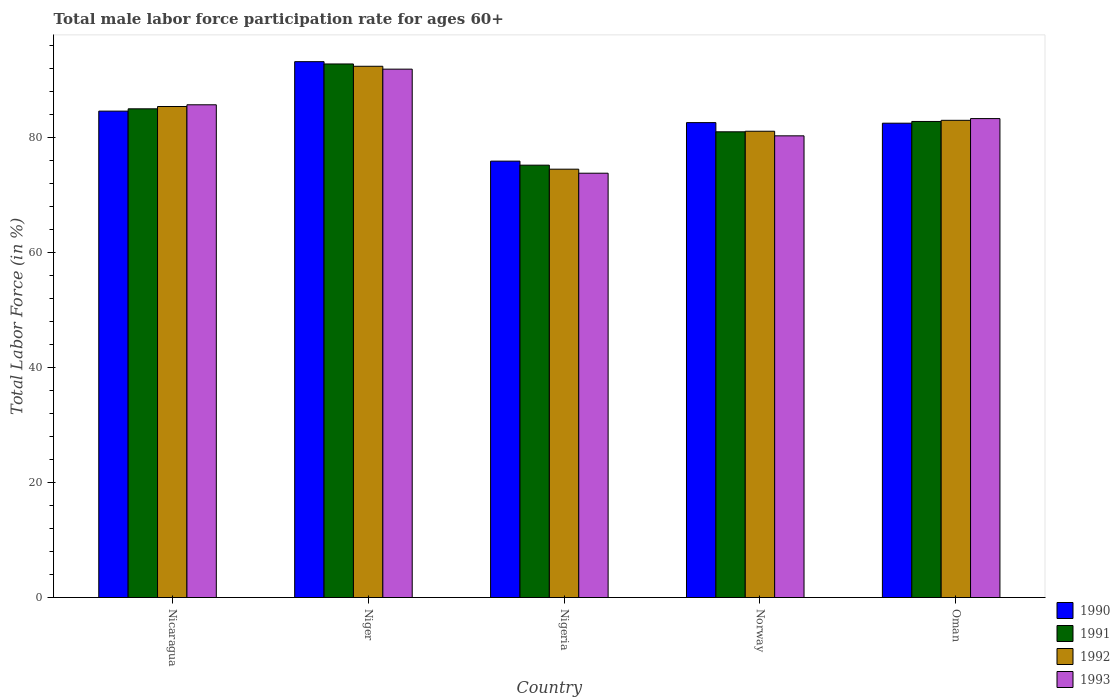Are the number of bars per tick equal to the number of legend labels?
Give a very brief answer. Yes. What is the label of the 3rd group of bars from the left?
Provide a succinct answer. Nigeria. What is the male labor force participation rate in 1990 in Nigeria?
Ensure brevity in your answer.  75.9. Across all countries, what is the maximum male labor force participation rate in 1993?
Give a very brief answer. 91.9. Across all countries, what is the minimum male labor force participation rate in 1993?
Your response must be concise. 73.8. In which country was the male labor force participation rate in 1993 maximum?
Offer a very short reply. Niger. In which country was the male labor force participation rate in 1990 minimum?
Offer a terse response. Nigeria. What is the total male labor force participation rate in 1990 in the graph?
Provide a short and direct response. 418.8. What is the difference between the male labor force participation rate in 1992 in Niger and that in Norway?
Provide a short and direct response. 11.3. What is the difference between the male labor force participation rate in 1990 in Nigeria and the male labor force participation rate in 1992 in Niger?
Provide a short and direct response. -16.5. What is the average male labor force participation rate in 1990 per country?
Make the answer very short. 83.76. What is the difference between the male labor force participation rate of/in 1992 and male labor force participation rate of/in 1991 in Nigeria?
Keep it short and to the point. -0.7. What is the ratio of the male labor force participation rate in 1991 in Nicaragua to that in Niger?
Offer a very short reply. 0.92. Is the male labor force participation rate in 1990 in Nicaragua less than that in Niger?
Make the answer very short. Yes. What is the difference between the highest and the lowest male labor force participation rate in 1990?
Provide a succinct answer. 17.3. In how many countries, is the male labor force participation rate in 1990 greater than the average male labor force participation rate in 1990 taken over all countries?
Offer a very short reply. 2. Is it the case that in every country, the sum of the male labor force participation rate in 1990 and male labor force participation rate in 1993 is greater than the sum of male labor force participation rate in 1991 and male labor force participation rate in 1992?
Your answer should be compact. No. What does the 1st bar from the left in Nigeria represents?
Ensure brevity in your answer.  1990. What does the 2nd bar from the right in Oman represents?
Your answer should be compact. 1992. Is it the case that in every country, the sum of the male labor force participation rate in 1993 and male labor force participation rate in 1992 is greater than the male labor force participation rate in 1991?
Your answer should be compact. Yes. How many bars are there?
Keep it short and to the point. 20. How many countries are there in the graph?
Your answer should be compact. 5. Does the graph contain grids?
Give a very brief answer. No. What is the title of the graph?
Give a very brief answer. Total male labor force participation rate for ages 60+. What is the label or title of the X-axis?
Make the answer very short. Country. What is the label or title of the Y-axis?
Provide a short and direct response. Total Labor Force (in %). What is the Total Labor Force (in %) of 1990 in Nicaragua?
Ensure brevity in your answer.  84.6. What is the Total Labor Force (in %) in 1992 in Nicaragua?
Provide a short and direct response. 85.4. What is the Total Labor Force (in %) of 1993 in Nicaragua?
Offer a terse response. 85.7. What is the Total Labor Force (in %) of 1990 in Niger?
Provide a succinct answer. 93.2. What is the Total Labor Force (in %) in 1991 in Niger?
Offer a terse response. 92.8. What is the Total Labor Force (in %) in 1992 in Niger?
Your response must be concise. 92.4. What is the Total Labor Force (in %) of 1993 in Niger?
Your response must be concise. 91.9. What is the Total Labor Force (in %) in 1990 in Nigeria?
Give a very brief answer. 75.9. What is the Total Labor Force (in %) of 1991 in Nigeria?
Your answer should be compact. 75.2. What is the Total Labor Force (in %) in 1992 in Nigeria?
Keep it short and to the point. 74.5. What is the Total Labor Force (in %) of 1993 in Nigeria?
Provide a short and direct response. 73.8. What is the Total Labor Force (in %) in 1990 in Norway?
Keep it short and to the point. 82.6. What is the Total Labor Force (in %) in 1992 in Norway?
Ensure brevity in your answer.  81.1. What is the Total Labor Force (in %) of 1993 in Norway?
Provide a short and direct response. 80.3. What is the Total Labor Force (in %) in 1990 in Oman?
Keep it short and to the point. 82.5. What is the Total Labor Force (in %) in 1991 in Oman?
Keep it short and to the point. 82.8. What is the Total Labor Force (in %) of 1992 in Oman?
Offer a terse response. 83. What is the Total Labor Force (in %) of 1993 in Oman?
Provide a succinct answer. 83.3. Across all countries, what is the maximum Total Labor Force (in %) in 1990?
Your response must be concise. 93.2. Across all countries, what is the maximum Total Labor Force (in %) of 1991?
Offer a terse response. 92.8. Across all countries, what is the maximum Total Labor Force (in %) of 1992?
Provide a short and direct response. 92.4. Across all countries, what is the maximum Total Labor Force (in %) of 1993?
Ensure brevity in your answer.  91.9. Across all countries, what is the minimum Total Labor Force (in %) in 1990?
Provide a short and direct response. 75.9. Across all countries, what is the minimum Total Labor Force (in %) of 1991?
Provide a succinct answer. 75.2. Across all countries, what is the minimum Total Labor Force (in %) in 1992?
Provide a succinct answer. 74.5. Across all countries, what is the minimum Total Labor Force (in %) of 1993?
Provide a succinct answer. 73.8. What is the total Total Labor Force (in %) of 1990 in the graph?
Provide a short and direct response. 418.8. What is the total Total Labor Force (in %) in 1991 in the graph?
Offer a very short reply. 416.8. What is the total Total Labor Force (in %) in 1992 in the graph?
Offer a terse response. 416.4. What is the total Total Labor Force (in %) in 1993 in the graph?
Your answer should be compact. 415. What is the difference between the Total Labor Force (in %) in 1991 in Nicaragua and that in Niger?
Your answer should be compact. -7.8. What is the difference between the Total Labor Force (in %) in 1992 in Nicaragua and that in Niger?
Your answer should be very brief. -7. What is the difference between the Total Labor Force (in %) in 1990 in Nicaragua and that in Nigeria?
Make the answer very short. 8.7. What is the difference between the Total Labor Force (in %) in 1992 in Nicaragua and that in Nigeria?
Your answer should be very brief. 10.9. What is the difference between the Total Labor Force (in %) in 1993 in Nicaragua and that in Norway?
Your response must be concise. 5.4. What is the difference between the Total Labor Force (in %) in 1990 in Nicaragua and that in Oman?
Ensure brevity in your answer.  2.1. What is the difference between the Total Labor Force (in %) in 1991 in Nicaragua and that in Oman?
Provide a succinct answer. 2.2. What is the difference between the Total Labor Force (in %) of 1992 in Nicaragua and that in Oman?
Offer a terse response. 2.4. What is the difference between the Total Labor Force (in %) in 1993 in Nicaragua and that in Oman?
Provide a short and direct response. 2.4. What is the difference between the Total Labor Force (in %) of 1990 in Niger and that in Nigeria?
Your response must be concise. 17.3. What is the difference between the Total Labor Force (in %) of 1991 in Niger and that in Nigeria?
Offer a very short reply. 17.6. What is the difference between the Total Labor Force (in %) in 1992 in Niger and that in Nigeria?
Provide a short and direct response. 17.9. What is the difference between the Total Labor Force (in %) in 1993 in Niger and that in Nigeria?
Your response must be concise. 18.1. What is the difference between the Total Labor Force (in %) in 1991 in Niger and that in Norway?
Offer a terse response. 11.8. What is the difference between the Total Labor Force (in %) in 1992 in Niger and that in Norway?
Keep it short and to the point. 11.3. What is the difference between the Total Labor Force (in %) in 1991 in Niger and that in Oman?
Your answer should be compact. 10. What is the difference between the Total Labor Force (in %) in 1991 in Nigeria and that in Norway?
Make the answer very short. -5.8. What is the difference between the Total Labor Force (in %) of 1993 in Nigeria and that in Norway?
Your answer should be compact. -6.5. What is the difference between the Total Labor Force (in %) in 1990 in Nigeria and that in Oman?
Give a very brief answer. -6.6. What is the difference between the Total Labor Force (in %) of 1992 in Nigeria and that in Oman?
Provide a succinct answer. -8.5. What is the difference between the Total Labor Force (in %) in 1990 in Norway and that in Oman?
Provide a short and direct response. 0.1. What is the difference between the Total Labor Force (in %) of 1992 in Norway and that in Oman?
Ensure brevity in your answer.  -1.9. What is the difference between the Total Labor Force (in %) in 1990 in Nicaragua and the Total Labor Force (in %) in 1991 in Niger?
Provide a succinct answer. -8.2. What is the difference between the Total Labor Force (in %) of 1990 in Nicaragua and the Total Labor Force (in %) of 1992 in Niger?
Your answer should be compact. -7.8. What is the difference between the Total Labor Force (in %) of 1990 in Nicaragua and the Total Labor Force (in %) of 1993 in Niger?
Ensure brevity in your answer.  -7.3. What is the difference between the Total Labor Force (in %) in 1991 in Nicaragua and the Total Labor Force (in %) in 1992 in Niger?
Your answer should be compact. -7.4. What is the difference between the Total Labor Force (in %) of 1990 in Nicaragua and the Total Labor Force (in %) of 1992 in Nigeria?
Provide a succinct answer. 10.1. What is the difference between the Total Labor Force (in %) of 1992 in Nicaragua and the Total Labor Force (in %) of 1993 in Nigeria?
Your response must be concise. 11.6. What is the difference between the Total Labor Force (in %) of 1990 in Nicaragua and the Total Labor Force (in %) of 1991 in Norway?
Your answer should be compact. 3.6. What is the difference between the Total Labor Force (in %) of 1990 in Nicaragua and the Total Labor Force (in %) of 1992 in Norway?
Ensure brevity in your answer.  3.5. What is the difference between the Total Labor Force (in %) in 1990 in Nicaragua and the Total Labor Force (in %) in 1993 in Norway?
Give a very brief answer. 4.3. What is the difference between the Total Labor Force (in %) in 1991 in Nicaragua and the Total Labor Force (in %) in 1993 in Norway?
Your answer should be very brief. 4.7. What is the difference between the Total Labor Force (in %) of 1990 in Nicaragua and the Total Labor Force (in %) of 1991 in Oman?
Make the answer very short. 1.8. What is the difference between the Total Labor Force (in %) of 1990 in Nicaragua and the Total Labor Force (in %) of 1993 in Oman?
Ensure brevity in your answer.  1.3. What is the difference between the Total Labor Force (in %) of 1991 in Nicaragua and the Total Labor Force (in %) of 1992 in Oman?
Make the answer very short. 2. What is the difference between the Total Labor Force (in %) in 1991 in Nicaragua and the Total Labor Force (in %) in 1993 in Oman?
Provide a short and direct response. 1.7. What is the difference between the Total Labor Force (in %) of 1992 in Nicaragua and the Total Labor Force (in %) of 1993 in Oman?
Your answer should be very brief. 2.1. What is the difference between the Total Labor Force (in %) in 1990 in Niger and the Total Labor Force (in %) in 1992 in Nigeria?
Ensure brevity in your answer.  18.7. What is the difference between the Total Labor Force (in %) of 1990 in Niger and the Total Labor Force (in %) of 1993 in Nigeria?
Provide a succinct answer. 19.4. What is the difference between the Total Labor Force (in %) in 1992 in Niger and the Total Labor Force (in %) in 1993 in Nigeria?
Offer a very short reply. 18.6. What is the difference between the Total Labor Force (in %) in 1990 in Niger and the Total Labor Force (in %) in 1992 in Norway?
Provide a succinct answer. 12.1. What is the difference between the Total Labor Force (in %) of 1990 in Niger and the Total Labor Force (in %) of 1993 in Norway?
Your answer should be compact. 12.9. What is the difference between the Total Labor Force (in %) of 1991 in Niger and the Total Labor Force (in %) of 1992 in Norway?
Make the answer very short. 11.7. What is the difference between the Total Labor Force (in %) of 1992 in Niger and the Total Labor Force (in %) of 1993 in Norway?
Your answer should be very brief. 12.1. What is the difference between the Total Labor Force (in %) of 1990 in Niger and the Total Labor Force (in %) of 1992 in Oman?
Your answer should be compact. 10.2. What is the difference between the Total Labor Force (in %) of 1991 in Niger and the Total Labor Force (in %) of 1993 in Oman?
Provide a short and direct response. 9.5. What is the difference between the Total Labor Force (in %) in 1992 in Niger and the Total Labor Force (in %) in 1993 in Oman?
Your response must be concise. 9.1. What is the difference between the Total Labor Force (in %) of 1990 in Nigeria and the Total Labor Force (in %) of 1991 in Norway?
Offer a very short reply. -5.1. What is the difference between the Total Labor Force (in %) in 1991 in Nigeria and the Total Labor Force (in %) in 1992 in Norway?
Give a very brief answer. -5.9. What is the difference between the Total Labor Force (in %) of 1992 in Nigeria and the Total Labor Force (in %) of 1993 in Norway?
Your response must be concise. -5.8. What is the difference between the Total Labor Force (in %) in 1990 in Nigeria and the Total Labor Force (in %) in 1993 in Oman?
Provide a succinct answer. -7.4. What is the difference between the Total Labor Force (in %) of 1991 in Nigeria and the Total Labor Force (in %) of 1992 in Oman?
Your answer should be very brief. -7.8. What is the difference between the Total Labor Force (in %) in 1991 in Nigeria and the Total Labor Force (in %) in 1993 in Oman?
Give a very brief answer. -8.1. What is the difference between the Total Labor Force (in %) in 1992 in Nigeria and the Total Labor Force (in %) in 1993 in Oman?
Give a very brief answer. -8.8. What is the difference between the Total Labor Force (in %) of 1990 in Norway and the Total Labor Force (in %) of 1991 in Oman?
Offer a terse response. -0.2. What is the difference between the Total Labor Force (in %) in 1990 in Norway and the Total Labor Force (in %) in 1993 in Oman?
Your answer should be very brief. -0.7. What is the average Total Labor Force (in %) of 1990 per country?
Provide a succinct answer. 83.76. What is the average Total Labor Force (in %) in 1991 per country?
Your response must be concise. 83.36. What is the average Total Labor Force (in %) in 1992 per country?
Ensure brevity in your answer.  83.28. What is the average Total Labor Force (in %) in 1993 per country?
Ensure brevity in your answer.  83. What is the difference between the Total Labor Force (in %) in 1990 and Total Labor Force (in %) in 1991 in Nicaragua?
Your response must be concise. -0.4. What is the difference between the Total Labor Force (in %) of 1990 and Total Labor Force (in %) of 1993 in Nicaragua?
Your response must be concise. -1.1. What is the difference between the Total Labor Force (in %) of 1990 and Total Labor Force (in %) of 1993 in Niger?
Provide a short and direct response. 1.3. What is the difference between the Total Labor Force (in %) of 1991 and Total Labor Force (in %) of 1992 in Nigeria?
Give a very brief answer. 0.7. What is the difference between the Total Labor Force (in %) of 1991 and Total Labor Force (in %) of 1993 in Nigeria?
Your answer should be compact. 1.4. What is the difference between the Total Labor Force (in %) in 1991 and Total Labor Force (in %) in 1992 in Norway?
Your answer should be compact. -0.1. What is the difference between the Total Labor Force (in %) in 1992 and Total Labor Force (in %) in 1993 in Norway?
Ensure brevity in your answer.  0.8. What is the difference between the Total Labor Force (in %) of 1990 and Total Labor Force (in %) of 1993 in Oman?
Your answer should be compact. -0.8. What is the difference between the Total Labor Force (in %) in 1991 and Total Labor Force (in %) in 1993 in Oman?
Your answer should be compact. -0.5. What is the difference between the Total Labor Force (in %) in 1992 and Total Labor Force (in %) in 1993 in Oman?
Ensure brevity in your answer.  -0.3. What is the ratio of the Total Labor Force (in %) of 1990 in Nicaragua to that in Niger?
Give a very brief answer. 0.91. What is the ratio of the Total Labor Force (in %) of 1991 in Nicaragua to that in Niger?
Keep it short and to the point. 0.92. What is the ratio of the Total Labor Force (in %) of 1992 in Nicaragua to that in Niger?
Offer a terse response. 0.92. What is the ratio of the Total Labor Force (in %) in 1993 in Nicaragua to that in Niger?
Ensure brevity in your answer.  0.93. What is the ratio of the Total Labor Force (in %) in 1990 in Nicaragua to that in Nigeria?
Your answer should be compact. 1.11. What is the ratio of the Total Labor Force (in %) in 1991 in Nicaragua to that in Nigeria?
Your answer should be compact. 1.13. What is the ratio of the Total Labor Force (in %) in 1992 in Nicaragua to that in Nigeria?
Your answer should be very brief. 1.15. What is the ratio of the Total Labor Force (in %) in 1993 in Nicaragua to that in Nigeria?
Offer a very short reply. 1.16. What is the ratio of the Total Labor Force (in %) of 1990 in Nicaragua to that in Norway?
Your response must be concise. 1.02. What is the ratio of the Total Labor Force (in %) in 1991 in Nicaragua to that in Norway?
Ensure brevity in your answer.  1.05. What is the ratio of the Total Labor Force (in %) in 1992 in Nicaragua to that in Norway?
Provide a succinct answer. 1.05. What is the ratio of the Total Labor Force (in %) of 1993 in Nicaragua to that in Norway?
Your answer should be compact. 1.07. What is the ratio of the Total Labor Force (in %) of 1990 in Nicaragua to that in Oman?
Provide a short and direct response. 1.03. What is the ratio of the Total Labor Force (in %) in 1991 in Nicaragua to that in Oman?
Your answer should be compact. 1.03. What is the ratio of the Total Labor Force (in %) of 1992 in Nicaragua to that in Oman?
Your response must be concise. 1.03. What is the ratio of the Total Labor Force (in %) of 1993 in Nicaragua to that in Oman?
Your answer should be very brief. 1.03. What is the ratio of the Total Labor Force (in %) of 1990 in Niger to that in Nigeria?
Your answer should be compact. 1.23. What is the ratio of the Total Labor Force (in %) in 1991 in Niger to that in Nigeria?
Make the answer very short. 1.23. What is the ratio of the Total Labor Force (in %) of 1992 in Niger to that in Nigeria?
Your answer should be very brief. 1.24. What is the ratio of the Total Labor Force (in %) in 1993 in Niger to that in Nigeria?
Provide a short and direct response. 1.25. What is the ratio of the Total Labor Force (in %) in 1990 in Niger to that in Norway?
Offer a terse response. 1.13. What is the ratio of the Total Labor Force (in %) in 1991 in Niger to that in Norway?
Your answer should be very brief. 1.15. What is the ratio of the Total Labor Force (in %) in 1992 in Niger to that in Norway?
Your answer should be very brief. 1.14. What is the ratio of the Total Labor Force (in %) in 1993 in Niger to that in Norway?
Provide a succinct answer. 1.14. What is the ratio of the Total Labor Force (in %) in 1990 in Niger to that in Oman?
Make the answer very short. 1.13. What is the ratio of the Total Labor Force (in %) in 1991 in Niger to that in Oman?
Your response must be concise. 1.12. What is the ratio of the Total Labor Force (in %) of 1992 in Niger to that in Oman?
Provide a short and direct response. 1.11. What is the ratio of the Total Labor Force (in %) in 1993 in Niger to that in Oman?
Your answer should be compact. 1.1. What is the ratio of the Total Labor Force (in %) in 1990 in Nigeria to that in Norway?
Your response must be concise. 0.92. What is the ratio of the Total Labor Force (in %) of 1991 in Nigeria to that in Norway?
Offer a very short reply. 0.93. What is the ratio of the Total Labor Force (in %) in 1992 in Nigeria to that in Norway?
Make the answer very short. 0.92. What is the ratio of the Total Labor Force (in %) in 1993 in Nigeria to that in Norway?
Your answer should be very brief. 0.92. What is the ratio of the Total Labor Force (in %) of 1990 in Nigeria to that in Oman?
Your answer should be compact. 0.92. What is the ratio of the Total Labor Force (in %) in 1991 in Nigeria to that in Oman?
Provide a succinct answer. 0.91. What is the ratio of the Total Labor Force (in %) of 1992 in Nigeria to that in Oman?
Offer a terse response. 0.9. What is the ratio of the Total Labor Force (in %) of 1993 in Nigeria to that in Oman?
Your answer should be compact. 0.89. What is the ratio of the Total Labor Force (in %) in 1990 in Norway to that in Oman?
Offer a terse response. 1. What is the ratio of the Total Labor Force (in %) of 1991 in Norway to that in Oman?
Offer a terse response. 0.98. What is the ratio of the Total Labor Force (in %) of 1992 in Norway to that in Oman?
Ensure brevity in your answer.  0.98. What is the ratio of the Total Labor Force (in %) in 1993 in Norway to that in Oman?
Ensure brevity in your answer.  0.96. What is the difference between the highest and the second highest Total Labor Force (in %) of 1990?
Give a very brief answer. 8.6. What is the difference between the highest and the second highest Total Labor Force (in %) of 1993?
Ensure brevity in your answer.  6.2. What is the difference between the highest and the lowest Total Labor Force (in %) in 1990?
Make the answer very short. 17.3. What is the difference between the highest and the lowest Total Labor Force (in %) of 1992?
Offer a very short reply. 17.9. 